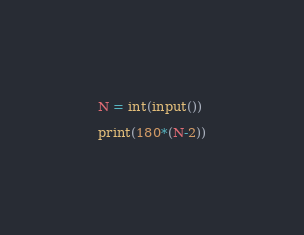<code> <loc_0><loc_0><loc_500><loc_500><_Python_>N = int(input())

print(180*(N-2))</code> 